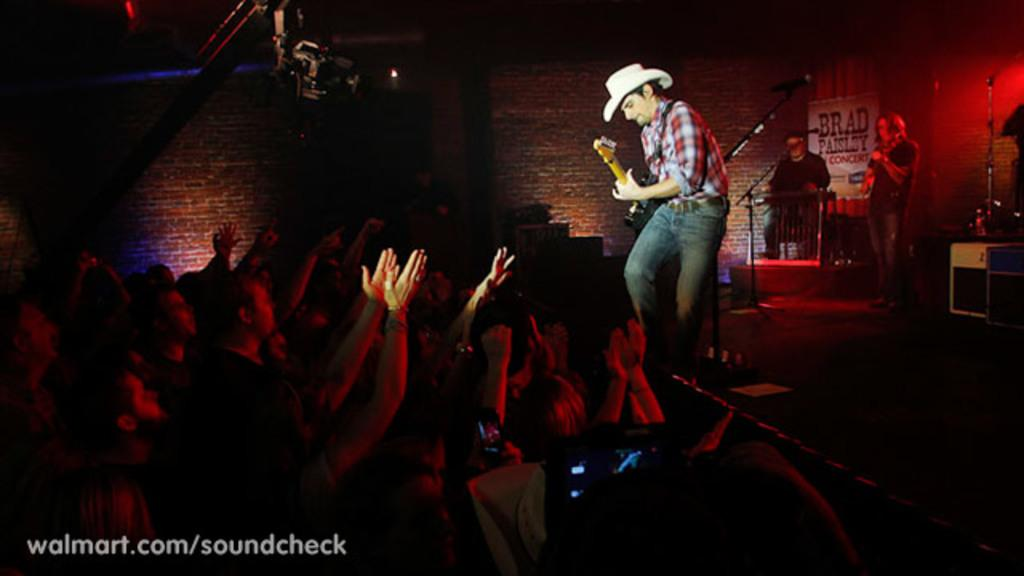What are the people in the image doing? The people in the image are playing musical instruments and listening to the music. What can be seen in the background of the image? There is a red wall with bricks visible in the background of the image. What type of son is playing the hook in the image? There is no son or hook present in the image; the people are playing musical instruments and listening to the music. 